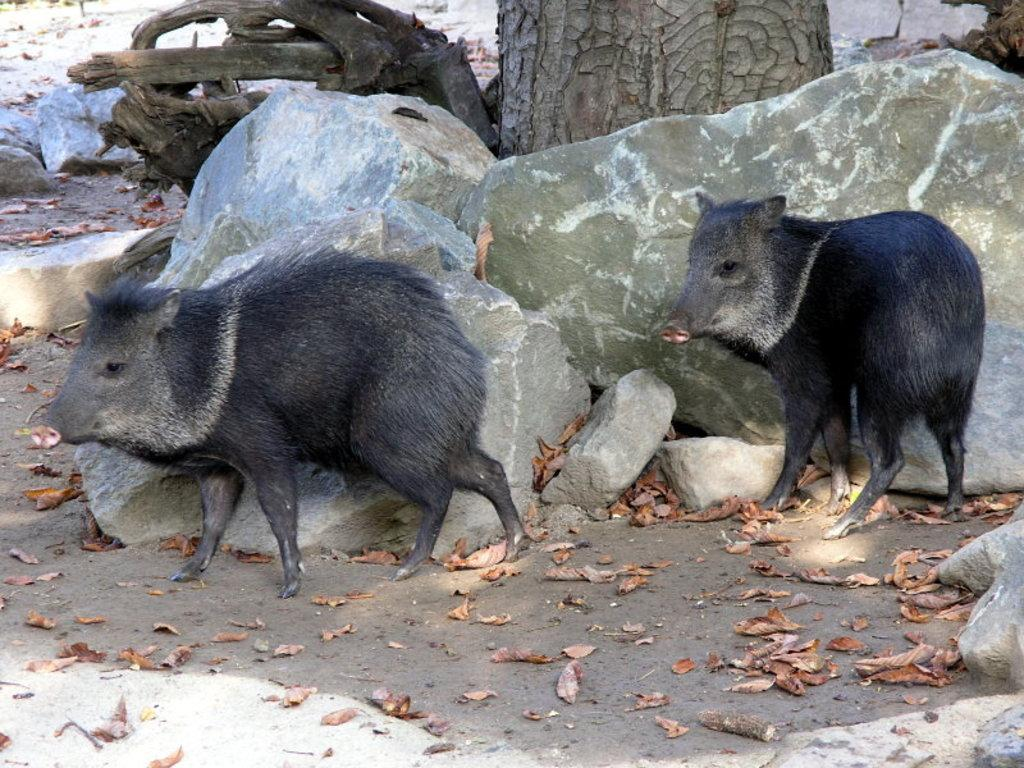What animals are in the image? There are pigs in the image. What type of natural objects can be seen in the image? There are stones and dried leaves on the ground in the image. What material is used for the objects visible in the background? There are wooden pieces visible in the background of the image. Can you tell me how many owls are sitting on the pigs in the image? There are no owls present in the image; it only features pigs, stones, dried leaves, and wooden pieces. What part of the image is the self located in? The concept of "self" is not applicable to the image, as it only contains inanimate objects and animals. 